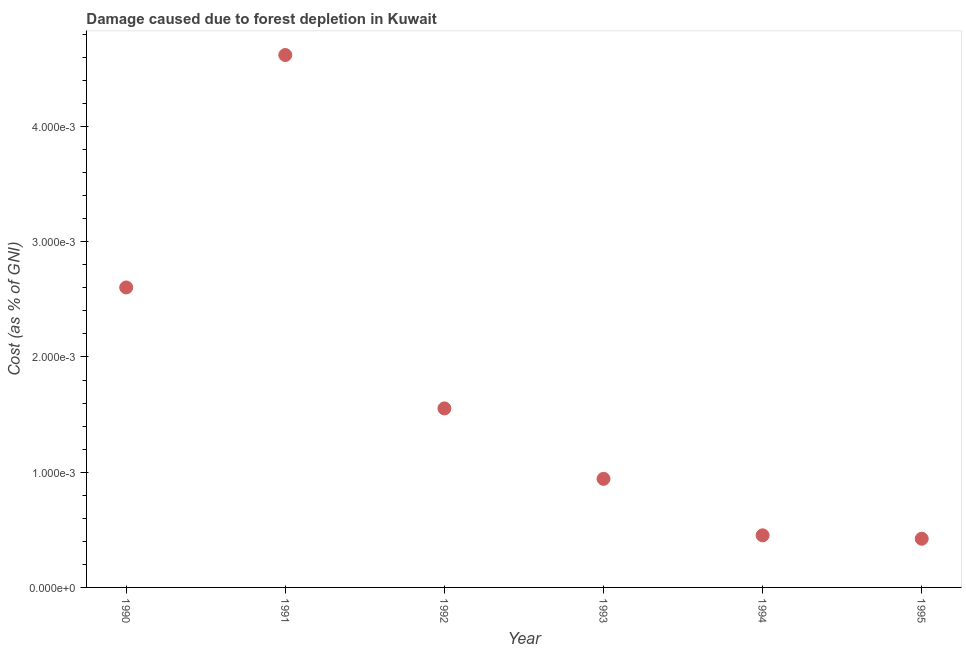What is the damage caused due to forest depletion in 1990?
Your answer should be very brief. 0. Across all years, what is the maximum damage caused due to forest depletion?
Provide a short and direct response. 0. Across all years, what is the minimum damage caused due to forest depletion?
Your response must be concise. 0. In which year was the damage caused due to forest depletion minimum?
Offer a very short reply. 1995. What is the sum of the damage caused due to forest depletion?
Your answer should be compact. 0.01. What is the difference between the damage caused due to forest depletion in 1992 and 1993?
Your response must be concise. 0. What is the average damage caused due to forest depletion per year?
Provide a succinct answer. 0. What is the median damage caused due to forest depletion?
Offer a very short reply. 0. What is the ratio of the damage caused due to forest depletion in 1992 to that in 1994?
Your response must be concise. 3.44. Is the difference between the damage caused due to forest depletion in 1990 and 1995 greater than the difference between any two years?
Ensure brevity in your answer.  No. What is the difference between the highest and the second highest damage caused due to forest depletion?
Keep it short and to the point. 0. Is the sum of the damage caused due to forest depletion in 1993 and 1995 greater than the maximum damage caused due to forest depletion across all years?
Your answer should be compact. No. What is the difference between the highest and the lowest damage caused due to forest depletion?
Offer a very short reply. 0. In how many years, is the damage caused due to forest depletion greater than the average damage caused due to forest depletion taken over all years?
Offer a very short reply. 2. Does the damage caused due to forest depletion monotonically increase over the years?
Offer a very short reply. No. What is the difference between two consecutive major ticks on the Y-axis?
Your response must be concise. 0. Are the values on the major ticks of Y-axis written in scientific E-notation?
Give a very brief answer. Yes. Does the graph contain any zero values?
Your answer should be compact. No. Does the graph contain grids?
Your response must be concise. No. What is the title of the graph?
Your response must be concise. Damage caused due to forest depletion in Kuwait. What is the label or title of the Y-axis?
Make the answer very short. Cost (as % of GNI). What is the Cost (as % of GNI) in 1990?
Provide a succinct answer. 0. What is the Cost (as % of GNI) in 1991?
Give a very brief answer. 0. What is the Cost (as % of GNI) in 1992?
Your answer should be very brief. 0. What is the Cost (as % of GNI) in 1993?
Offer a very short reply. 0. What is the Cost (as % of GNI) in 1994?
Make the answer very short. 0. What is the Cost (as % of GNI) in 1995?
Keep it short and to the point. 0. What is the difference between the Cost (as % of GNI) in 1990 and 1991?
Make the answer very short. -0. What is the difference between the Cost (as % of GNI) in 1990 and 1992?
Provide a succinct answer. 0. What is the difference between the Cost (as % of GNI) in 1990 and 1993?
Your answer should be very brief. 0. What is the difference between the Cost (as % of GNI) in 1990 and 1994?
Ensure brevity in your answer.  0. What is the difference between the Cost (as % of GNI) in 1990 and 1995?
Your answer should be very brief. 0. What is the difference between the Cost (as % of GNI) in 1991 and 1992?
Offer a very short reply. 0. What is the difference between the Cost (as % of GNI) in 1991 and 1993?
Provide a short and direct response. 0. What is the difference between the Cost (as % of GNI) in 1991 and 1994?
Ensure brevity in your answer.  0. What is the difference between the Cost (as % of GNI) in 1991 and 1995?
Ensure brevity in your answer.  0. What is the difference between the Cost (as % of GNI) in 1992 and 1993?
Offer a terse response. 0. What is the difference between the Cost (as % of GNI) in 1992 and 1994?
Give a very brief answer. 0. What is the difference between the Cost (as % of GNI) in 1992 and 1995?
Your answer should be compact. 0. What is the difference between the Cost (as % of GNI) in 1993 and 1994?
Keep it short and to the point. 0. What is the difference between the Cost (as % of GNI) in 1993 and 1995?
Offer a terse response. 0. What is the difference between the Cost (as % of GNI) in 1994 and 1995?
Your response must be concise. 3e-5. What is the ratio of the Cost (as % of GNI) in 1990 to that in 1991?
Offer a terse response. 0.56. What is the ratio of the Cost (as % of GNI) in 1990 to that in 1992?
Provide a succinct answer. 1.68. What is the ratio of the Cost (as % of GNI) in 1990 to that in 1993?
Your answer should be compact. 2.76. What is the ratio of the Cost (as % of GNI) in 1990 to that in 1994?
Provide a short and direct response. 5.76. What is the ratio of the Cost (as % of GNI) in 1990 to that in 1995?
Your response must be concise. 6.16. What is the ratio of the Cost (as % of GNI) in 1991 to that in 1992?
Give a very brief answer. 2.97. What is the ratio of the Cost (as % of GNI) in 1991 to that in 1993?
Provide a succinct answer. 4.9. What is the ratio of the Cost (as % of GNI) in 1991 to that in 1994?
Your response must be concise. 10.22. What is the ratio of the Cost (as % of GNI) in 1991 to that in 1995?
Make the answer very short. 10.94. What is the ratio of the Cost (as % of GNI) in 1992 to that in 1993?
Provide a succinct answer. 1.65. What is the ratio of the Cost (as % of GNI) in 1992 to that in 1994?
Provide a succinct answer. 3.44. What is the ratio of the Cost (as % of GNI) in 1992 to that in 1995?
Keep it short and to the point. 3.68. What is the ratio of the Cost (as % of GNI) in 1993 to that in 1994?
Ensure brevity in your answer.  2.08. What is the ratio of the Cost (as % of GNI) in 1993 to that in 1995?
Your response must be concise. 2.23. What is the ratio of the Cost (as % of GNI) in 1994 to that in 1995?
Your answer should be very brief. 1.07. 